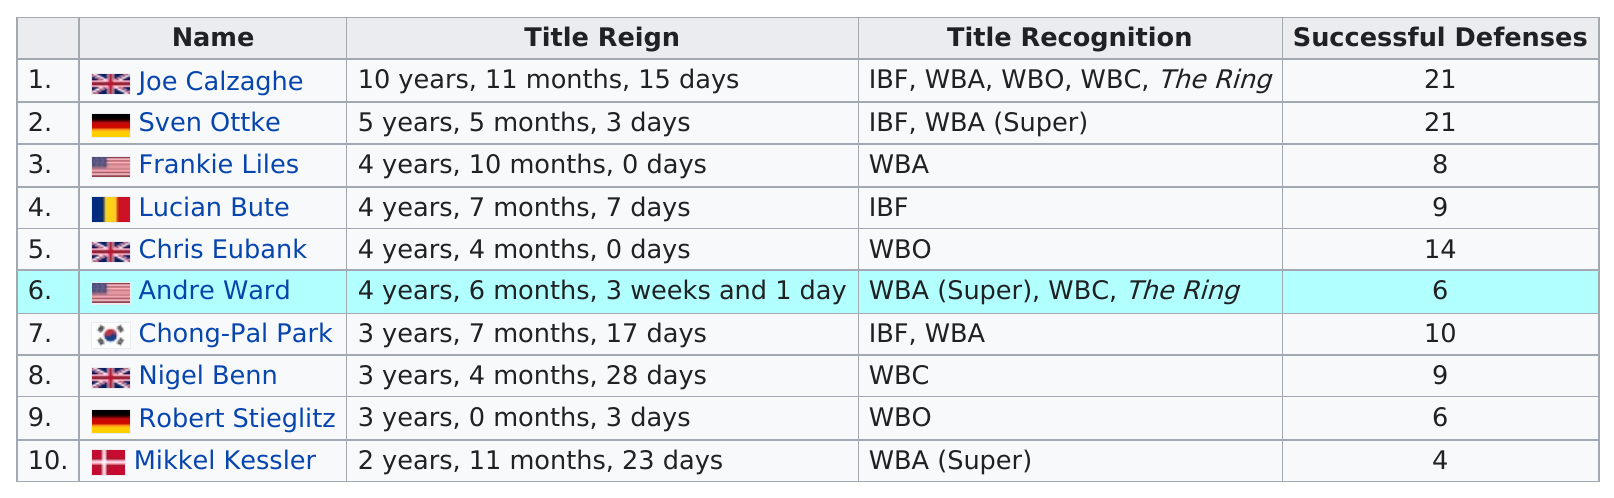Mention a couple of crucial points in this snapshot. The number of successful defenses by Joe Calzaghe and Robert Stieglitz is 15. Joe Calzaghe and Sven Ottke were the most successful at defending their titles, with their respective undefeated records and numerous successful title defenses. The longest title reign after champion Joe Calzaghe was 5 years, 5 months, and 3 days. Both Joe Calzaghe and Sven Ottke, the two current super middleweight champions, have achieved a similar number of successful title defenses. Out of the fighters with more than 10 successful title defenses, only 3 were able to achieve this feat. 